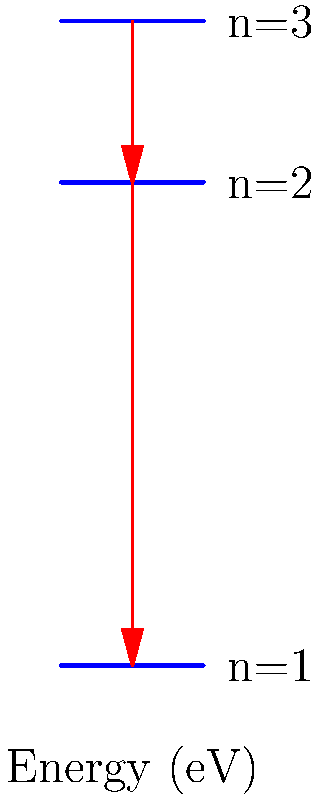In the energy level diagram for a hydrogen atom shown above, an electron transitions from the n=3 state to the n=1 state. What is the total energy (in eV) emitted during this transition? Round your answer to one decimal place. To solve this problem, we need to follow these steps:

1. Identify the energy levels:
   n=3: E₃ = 0 eV
   n=2: E₂ = -3.4 eV
   n=1: E₁ = -13.6 eV

2. Calculate the energy difference between n=3 and n=1:
   ΔE = E₁ - E₃
   ΔE = -13.6 eV - 0 eV
   ΔE = -13.6 eV

3. The negative sign indicates that energy is released (emitted) during the transition.

4. Take the absolute value of the energy difference to get the emitted energy:
   Emitted Energy = |ΔE| = |-13.6 eV| = 13.6 eV

5. Round to one decimal place:
   13.6 eV (already in the correct format)

Therefore, the total energy emitted during the transition from n=3 to n=1 is 13.6 eV.
Answer: 13.6 eV 